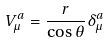Convert formula to latex. <formula><loc_0><loc_0><loc_500><loc_500>V ^ { a } _ { \mu } = \frac { r } { \cos \theta } \delta ^ { a } _ { \mu }</formula> 